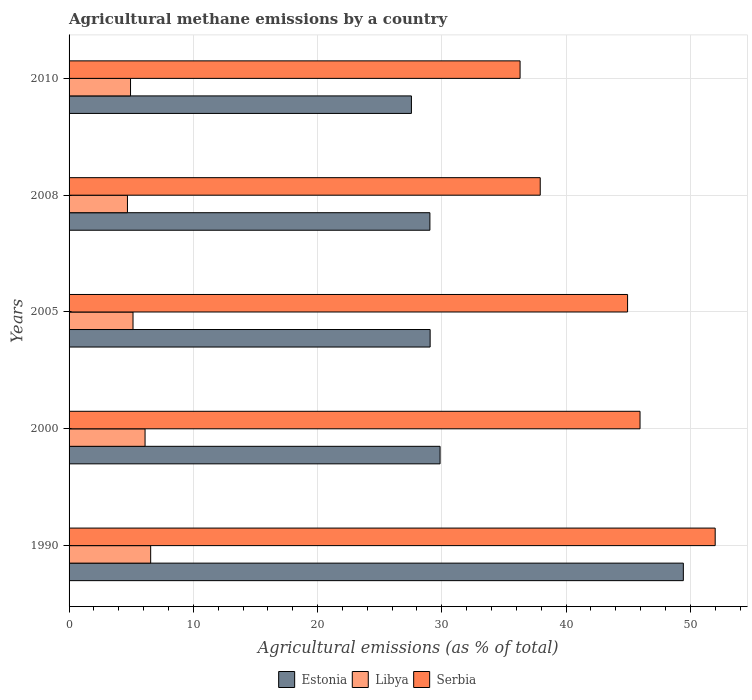How many different coloured bars are there?
Your response must be concise. 3. How many groups of bars are there?
Give a very brief answer. 5. Are the number of bars on each tick of the Y-axis equal?
Your answer should be compact. Yes. What is the label of the 5th group of bars from the top?
Make the answer very short. 1990. What is the amount of agricultural methane emitted in Estonia in 2005?
Keep it short and to the point. 29.06. Across all years, what is the maximum amount of agricultural methane emitted in Serbia?
Keep it short and to the point. 52. Across all years, what is the minimum amount of agricultural methane emitted in Libya?
Your response must be concise. 4.7. What is the total amount of agricultural methane emitted in Serbia in the graph?
Keep it short and to the point. 217.12. What is the difference between the amount of agricultural methane emitted in Libya in 1990 and that in 2010?
Your answer should be very brief. 1.62. What is the difference between the amount of agricultural methane emitted in Serbia in 2005 and the amount of agricultural methane emitted in Libya in 2008?
Your answer should be very brief. 40.25. What is the average amount of agricultural methane emitted in Estonia per year?
Ensure brevity in your answer.  32.99. In the year 2005, what is the difference between the amount of agricultural methane emitted in Estonia and amount of agricultural methane emitted in Serbia?
Your response must be concise. -15.89. What is the ratio of the amount of agricultural methane emitted in Serbia in 1990 to that in 2010?
Provide a succinct answer. 1.43. Is the amount of agricultural methane emitted in Estonia in 1990 less than that in 2005?
Your answer should be compact. No. Is the difference between the amount of agricultural methane emitted in Estonia in 1990 and 2005 greater than the difference between the amount of agricultural methane emitted in Serbia in 1990 and 2005?
Your answer should be very brief. Yes. What is the difference between the highest and the second highest amount of agricultural methane emitted in Libya?
Offer a terse response. 0.45. What is the difference between the highest and the lowest amount of agricultural methane emitted in Libya?
Offer a terse response. 1.87. In how many years, is the amount of agricultural methane emitted in Serbia greater than the average amount of agricultural methane emitted in Serbia taken over all years?
Your response must be concise. 3. Is the sum of the amount of agricultural methane emitted in Libya in 2005 and 2008 greater than the maximum amount of agricultural methane emitted in Serbia across all years?
Offer a terse response. No. What does the 1st bar from the top in 1990 represents?
Offer a terse response. Serbia. What does the 2nd bar from the bottom in 1990 represents?
Provide a succinct answer. Libya. Is it the case that in every year, the sum of the amount of agricultural methane emitted in Estonia and amount of agricultural methane emitted in Serbia is greater than the amount of agricultural methane emitted in Libya?
Your answer should be compact. Yes. How many bars are there?
Provide a succinct answer. 15. What is the difference between two consecutive major ticks on the X-axis?
Provide a succinct answer. 10. Are the values on the major ticks of X-axis written in scientific E-notation?
Your response must be concise. No. Where does the legend appear in the graph?
Offer a terse response. Bottom center. How many legend labels are there?
Keep it short and to the point. 3. What is the title of the graph?
Your answer should be very brief. Agricultural methane emissions by a country. What is the label or title of the X-axis?
Offer a very short reply. Agricultural emissions (as % of total). What is the label or title of the Y-axis?
Give a very brief answer. Years. What is the Agricultural emissions (as % of total) in Estonia in 1990?
Ensure brevity in your answer.  49.44. What is the Agricultural emissions (as % of total) of Libya in 1990?
Provide a succinct answer. 6.57. What is the Agricultural emissions (as % of total) in Serbia in 1990?
Your answer should be very brief. 52. What is the Agricultural emissions (as % of total) of Estonia in 2000?
Make the answer very short. 29.86. What is the Agricultural emissions (as % of total) in Libya in 2000?
Offer a very short reply. 6.12. What is the Agricultural emissions (as % of total) of Serbia in 2000?
Make the answer very short. 45.95. What is the Agricultural emissions (as % of total) in Estonia in 2005?
Keep it short and to the point. 29.06. What is the Agricultural emissions (as % of total) of Libya in 2005?
Your response must be concise. 5.15. What is the Agricultural emissions (as % of total) of Serbia in 2005?
Your answer should be very brief. 44.95. What is the Agricultural emissions (as % of total) in Estonia in 2008?
Your response must be concise. 29.04. What is the Agricultural emissions (as % of total) in Libya in 2008?
Give a very brief answer. 4.7. What is the Agricultural emissions (as % of total) of Serbia in 2008?
Provide a succinct answer. 37.92. What is the Agricultural emissions (as % of total) in Estonia in 2010?
Give a very brief answer. 27.55. What is the Agricultural emissions (as % of total) of Libya in 2010?
Keep it short and to the point. 4.95. What is the Agricultural emissions (as % of total) of Serbia in 2010?
Make the answer very short. 36.3. Across all years, what is the maximum Agricultural emissions (as % of total) in Estonia?
Your response must be concise. 49.44. Across all years, what is the maximum Agricultural emissions (as % of total) of Libya?
Provide a short and direct response. 6.57. Across all years, what is the maximum Agricultural emissions (as % of total) of Serbia?
Keep it short and to the point. 52. Across all years, what is the minimum Agricultural emissions (as % of total) of Estonia?
Make the answer very short. 27.55. Across all years, what is the minimum Agricultural emissions (as % of total) in Libya?
Ensure brevity in your answer.  4.7. Across all years, what is the minimum Agricultural emissions (as % of total) of Serbia?
Keep it short and to the point. 36.3. What is the total Agricultural emissions (as % of total) in Estonia in the graph?
Give a very brief answer. 164.95. What is the total Agricultural emissions (as % of total) of Libya in the graph?
Provide a succinct answer. 27.48. What is the total Agricultural emissions (as % of total) of Serbia in the graph?
Your answer should be very brief. 217.12. What is the difference between the Agricultural emissions (as % of total) in Estonia in 1990 and that in 2000?
Ensure brevity in your answer.  19.58. What is the difference between the Agricultural emissions (as % of total) in Libya in 1990 and that in 2000?
Ensure brevity in your answer.  0.45. What is the difference between the Agricultural emissions (as % of total) of Serbia in 1990 and that in 2000?
Make the answer very short. 6.05. What is the difference between the Agricultural emissions (as % of total) in Estonia in 1990 and that in 2005?
Make the answer very short. 20.38. What is the difference between the Agricultural emissions (as % of total) in Libya in 1990 and that in 2005?
Provide a short and direct response. 1.42. What is the difference between the Agricultural emissions (as % of total) in Serbia in 1990 and that in 2005?
Provide a succinct answer. 7.05. What is the difference between the Agricultural emissions (as % of total) of Estonia in 1990 and that in 2008?
Provide a short and direct response. 20.4. What is the difference between the Agricultural emissions (as % of total) in Libya in 1990 and that in 2008?
Your answer should be compact. 1.87. What is the difference between the Agricultural emissions (as % of total) in Serbia in 1990 and that in 2008?
Your response must be concise. 14.08. What is the difference between the Agricultural emissions (as % of total) in Estonia in 1990 and that in 2010?
Your answer should be very brief. 21.88. What is the difference between the Agricultural emissions (as % of total) in Libya in 1990 and that in 2010?
Your answer should be very brief. 1.62. What is the difference between the Agricultural emissions (as % of total) in Serbia in 1990 and that in 2010?
Ensure brevity in your answer.  15.7. What is the difference between the Agricultural emissions (as % of total) of Estonia in 2000 and that in 2005?
Ensure brevity in your answer.  0.8. What is the difference between the Agricultural emissions (as % of total) in Libya in 2000 and that in 2005?
Your answer should be very brief. 0.97. What is the difference between the Agricultural emissions (as % of total) of Estonia in 2000 and that in 2008?
Make the answer very short. 0.82. What is the difference between the Agricultural emissions (as % of total) in Libya in 2000 and that in 2008?
Give a very brief answer. 1.42. What is the difference between the Agricultural emissions (as % of total) of Serbia in 2000 and that in 2008?
Offer a terse response. 8.03. What is the difference between the Agricultural emissions (as % of total) of Estonia in 2000 and that in 2010?
Ensure brevity in your answer.  2.31. What is the difference between the Agricultural emissions (as % of total) of Libya in 2000 and that in 2010?
Ensure brevity in your answer.  1.17. What is the difference between the Agricultural emissions (as % of total) in Serbia in 2000 and that in 2010?
Make the answer very short. 9.65. What is the difference between the Agricultural emissions (as % of total) in Estonia in 2005 and that in 2008?
Offer a terse response. 0.02. What is the difference between the Agricultural emissions (as % of total) of Libya in 2005 and that in 2008?
Offer a very short reply. 0.45. What is the difference between the Agricultural emissions (as % of total) of Serbia in 2005 and that in 2008?
Ensure brevity in your answer.  7.03. What is the difference between the Agricultural emissions (as % of total) of Estonia in 2005 and that in 2010?
Provide a succinct answer. 1.51. What is the difference between the Agricultural emissions (as % of total) of Libya in 2005 and that in 2010?
Make the answer very short. 0.2. What is the difference between the Agricultural emissions (as % of total) in Serbia in 2005 and that in 2010?
Keep it short and to the point. 8.65. What is the difference between the Agricultural emissions (as % of total) of Estonia in 2008 and that in 2010?
Ensure brevity in your answer.  1.49. What is the difference between the Agricultural emissions (as % of total) in Libya in 2008 and that in 2010?
Offer a terse response. -0.25. What is the difference between the Agricultural emissions (as % of total) of Serbia in 2008 and that in 2010?
Make the answer very short. 1.62. What is the difference between the Agricultural emissions (as % of total) in Estonia in 1990 and the Agricultural emissions (as % of total) in Libya in 2000?
Provide a short and direct response. 43.32. What is the difference between the Agricultural emissions (as % of total) of Estonia in 1990 and the Agricultural emissions (as % of total) of Serbia in 2000?
Provide a succinct answer. 3.49. What is the difference between the Agricultural emissions (as % of total) of Libya in 1990 and the Agricultural emissions (as % of total) of Serbia in 2000?
Offer a very short reply. -39.38. What is the difference between the Agricultural emissions (as % of total) in Estonia in 1990 and the Agricultural emissions (as % of total) in Libya in 2005?
Ensure brevity in your answer.  44.29. What is the difference between the Agricultural emissions (as % of total) of Estonia in 1990 and the Agricultural emissions (as % of total) of Serbia in 2005?
Make the answer very short. 4.49. What is the difference between the Agricultural emissions (as % of total) of Libya in 1990 and the Agricultural emissions (as % of total) of Serbia in 2005?
Make the answer very short. -38.38. What is the difference between the Agricultural emissions (as % of total) in Estonia in 1990 and the Agricultural emissions (as % of total) in Libya in 2008?
Provide a succinct answer. 44.74. What is the difference between the Agricultural emissions (as % of total) of Estonia in 1990 and the Agricultural emissions (as % of total) of Serbia in 2008?
Your answer should be compact. 11.52. What is the difference between the Agricultural emissions (as % of total) of Libya in 1990 and the Agricultural emissions (as % of total) of Serbia in 2008?
Ensure brevity in your answer.  -31.35. What is the difference between the Agricultural emissions (as % of total) of Estonia in 1990 and the Agricultural emissions (as % of total) of Libya in 2010?
Provide a succinct answer. 44.49. What is the difference between the Agricultural emissions (as % of total) in Estonia in 1990 and the Agricultural emissions (as % of total) in Serbia in 2010?
Your answer should be compact. 13.14. What is the difference between the Agricultural emissions (as % of total) of Libya in 1990 and the Agricultural emissions (as % of total) of Serbia in 2010?
Your answer should be compact. -29.73. What is the difference between the Agricultural emissions (as % of total) of Estonia in 2000 and the Agricultural emissions (as % of total) of Libya in 2005?
Keep it short and to the point. 24.71. What is the difference between the Agricultural emissions (as % of total) of Estonia in 2000 and the Agricultural emissions (as % of total) of Serbia in 2005?
Give a very brief answer. -15.09. What is the difference between the Agricultural emissions (as % of total) of Libya in 2000 and the Agricultural emissions (as % of total) of Serbia in 2005?
Keep it short and to the point. -38.83. What is the difference between the Agricultural emissions (as % of total) of Estonia in 2000 and the Agricultural emissions (as % of total) of Libya in 2008?
Provide a succinct answer. 25.16. What is the difference between the Agricultural emissions (as % of total) of Estonia in 2000 and the Agricultural emissions (as % of total) of Serbia in 2008?
Your answer should be compact. -8.06. What is the difference between the Agricultural emissions (as % of total) in Libya in 2000 and the Agricultural emissions (as % of total) in Serbia in 2008?
Offer a terse response. -31.8. What is the difference between the Agricultural emissions (as % of total) of Estonia in 2000 and the Agricultural emissions (as % of total) of Libya in 2010?
Ensure brevity in your answer.  24.91. What is the difference between the Agricultural emissions (as % of total) in Estonia in 2000 and the Agricultural emissions (as % of total) in Serbia in 2010?
Your answer should be compact. -6.44. What is the difference between the Agricultural emissions (as % of total) of Libya in 2000 and the Agricultural emissions (as % of total) of Serbia in 2010?
Give a very brief answer. -30.18. What is the difference between the Agricultural emissions (as % of total) in Estonia in 2005 and the Agricultural emissions (as % of total) in Libya in 2008?
Ensure brevity in your answer.  24.36. What is the difference between the Agricultural emissions (as % of total) in Estonia in 2005 and the Agricultural emissions (as % of total) in Serbia in 2008?
Offer a terse response. -8.86. What is the difference between the Agricultural emissions (as % of total) of Libya in 2005 and the Agricultural emissions (as % of total) of Serbia in 2008?
Keep it short and to the point. -32.77. What is the difference between the Agricultural emissions (as % of total) of Estonia in 2005 and the Agricultural emissions (as % of total) of Libya in 2010?
Offer a very short reply. 24.11. What is the difference between the Agricultural emissions (as % of total) of Estonia in 2005 and the Agricultural emissions (as % of total) of Serbia in 2010?
Your response must be concise. -7.24. What is the difference between the Agricultural emissions (as % of total) in Libya in 2005 and the Agricultural emissions (as % of total) in Serbia in 2010?
Give a very brief answer. -31.15. What is the difference between the Agricultural emissions (as % of total) in Estonia in 2008 and the Agricultural emissions (as % of total) in Libya in 2010?
Offer a very short reply. 24.09. What is the difference between the Agricultural emissions (as % of total) of Estonia in 2008 and the Agricultural emissions (as % of total) of Serbia in 2010?
Your response must be concise. -7.26. What is the difference between the Agricultural emissions (as % of total) of Libya in 2008 and the Agricultural emissions (as % of total) of Serbia in 2010?
Provide a short and direct response. -31.6. What is the average Agricultural emissions (as % of total) in Estonia per year?
Your answer should be compact. 32.99. What is the average Agricultural emissions (as % of total) in Libya per year?
Make the answer very short. 5.5. What is the average Agricultural emissions (as % of total) of Serbia per year?
Make the answer very short. 43.42. In the year 1990, what is the difference between the Agricultural emissions (as % of total) in Estonia and Agricultural emissions (as % of total) in Libya?
Offer a terse response. 42.87. In the year 1990, what is the difference between the Agricultural emissions (as % of total) in Estonia and Agricultural emissions (as % of total) in Serbia?
Offer a terse response. -2.56. In the year 1990, what is the difference between the Agricultural emissions (as % of total) of Libya and Agricultural emissions (as % of total) of Serbia?
Offer a terse response. -45.43. In the year 2000, what is the difference between the Agricultural emissions (as % of total) of Estonia and Agricultural emissions (as % of total) of Libya?
Give a very brief answer. 23.74. In the year 2000, what is the difference between the Agricultural emissions (as % of total) in Estonia and Agricultural emissions (as % of total) in Serbia?
Provide a succinct answer. -16.09. In the year 2000, what is the difference between the Agricultural emissions (as % of total) of Libya and Agricultural emissions (as % of total) of Serbia?
Offer a very short reply. -39.84. In the year 2005, what is the difference between the Agricultural emissions (as % of total) in Estonia and Agricultural emissions (as % of total) in Libya?
Ensure brevity in your answer.  23.91. In the year 2005, what is the difference between the Agricultural emissions (as % of total) of Estonia and Agricultural emissions (as % of total) of Serbia?
Keep it short and to the point. -15.89. In the year 2005, what is the difference between the Agricultural emissions (as % of total) of Libya and Agricultural emissions (as % of total) of Serbia?
Your answer should be compact. -39.8. In the year 2008, what is the difference between the Agricultural emissions (as % of total) of Estonia and Agricultural emissions (as % of total) of Libya?
Make the answer very short. 24.34. In the year 2008, what is the difference between the Agricultural emissions (as % of total) in Estonia and Agricultural emissions (as % of total) in Serbia?
Provide a short and direct response. -8.88. In the year 2008, what is the difference between the Agricultural emissions (as % of total) of Libya and Agricultural emissions (as % of total) of Serbia?
Your response must be concise. -33.22. In the year 2010, what is the difference between the Agricultural emissions (as % of total) in Estonia and Agricultural emissions (as % of total) in Libya?
Provide a succinct answer. 22.61. In the year 2010, what is the difference between the Agricultural emissions (as % of total) of Estonia and Agricultural emissions (as % of total) of Serbia?
Your response must be concise. -8.74. In the year 2010, what is the difference between the Agricultural emissions (as % of total) in Libya and Agricultural emissions (as % of total) in Serbia?
Provide a short and direct response. -31.35. What is the ratio of the Agricultural emissions (as % of total) in Estonia in 1990 to that in 2000?
Give a very brief answer. 1.66. What is the ratio of the Agricultural emissions (as % of total) of Libya in 1990 to that in 2000?
Offer a very short reply. 1.07. What is the ratio of the Agricultural emissions (as % of total) in Serbia in 1990 to that in 2000?
Your response must be concise. 1.13. What is the ratio of the Agricultural emissions (as % of total) of Estonia in 1990 to that in 2005?
Your answer should be compact. 1.7. What is the ratio of the Agricultural emissions (as % of total) of Libya in 1990 to that in 2005?
Provide a succinct answer. 1.28. What is the ratio of the Agricultural emissions (as % of total) of Serbia in 1990 to that in 2005?
Your answer should be very brief. 1.16. What is the ratio of the Agricultural emissions (as % of total) in Estonia in 1990 to that in 2008?
Make the answer very short. 1.7. What is the ratio of the Agricultural emissions (as % of total) in Libya in 1990 to that in 2008?
Offer a terse response. 1.4. What is the ratio of the Agricultural emissions (as % of total) of Serbia in 1990 to that in 2008?
Your answer should be very brief. 1.37. What is the ratio of the Agricultural emissions (as % of total) in Estonia in 1990 to that in 2010?
Make the answer very short. 1.79. What is the ratio of the Agricultural emissions (as % of total) of Libya in 1990 to that in 2010?
Your answer should be very brief. 1.33. What is the ratio of the Agricultural emissions (as % of total) of Serbia in 1990 to that in 2010?
Your answer should be very brief. 1.43. What is the ratio of the Agricultural emissions (as % of total) of Estonia in 2000 to that in 2005?
Provide a succinct answer. 1.03. What is the ratio of the Agricultural emissions (as % of total) in Libya in 2000 to that in 2005?
Offer a terse response. 1.19. What is the ratio of the Agricultural emissions (as % of total) of Serbia in 2000 to that in 2005?
Your answer should be compact. 1.02. What is the ratio of the Agricultural emissions (as % of total) of Estonia in 2000 to that in 2008?
Your response must be concise. 1.03. What is the ratio of the Agricultural emissions (as % of total) in Libya in 2000 to that in 2008?
Give a very brief answer. 1.3. What is the ratio of the Agricultural emissions (as % of total) of Serbia in 2000 to that in 2008?
Provide a short and direct response. 1.21. What is the ratio of the Agricultural emissions (as % of total) in Estonia in 2000 to that in 2010?
Provide a short and direct response. 1.08. What is the ratio of the Agricultural emissions (as % of total) in Libya in 2000 to that in 2010?
Keep it short and to the point. 1.24. What is the ratio of the Agricultural emissions (as % of total) of Serbia in 2000 to that in 2010?
Give a very brief answer. 1.27. What is the ratio of the Agricultural emissions (as % of total) in Libya in 2005 to that in 2008?
Your answer should be very brief. 1.1. What is the ratio of the Agricultural emissions (as % of total) of Serbia in 2005 to that in 2008?
Make the answer very short. 1.19. What is the ratio of the Agricultural emissions (as % of total) in Estonia in 2005 to that in 2010?
Keep it short and to the point. 1.05. What is the ratio of the Agricultural emissions (as % of total) in Libya in 2005 to that in 2010?
Make the answer very short. 1.04. What is the ratio of the Agricultural emissions (as % of total) of Serbia in 2005 to that in 2010?
Make the answer very short. 1.24. What is the ratio of the Agricultural emissions (as % of total) of Estonia in 2008 to that in 2010?
Your answer should be very brief. 1.05. What is the ratio of the Agricultural emissions (as % of total) in Libya in 2008 to that in 2010?
Keep it short and to the point. 0.95. What is the ratio of the Agricultural emissions (as % of total) of Serbia in 2008 to that in 2010?
Give a very brief answer. 1.04. What is the difference between the highest and the second highest Agricultural emissions (as % of total) in Estonia?
Provide a succinct answer. 19.58. What is the difference between the highest and the second highest Agricultural emissions (as % of total) in Libya?
Your response must be concise. 0.45. What is the difference between the highest and the second highest Agricultural emissions (as % of total) of Serbia?
Make the answer very short. 6.05. What is the difference between the highest and the lowest Agricultural emissions (as % of total) in Estonia?
Offer a terse response. 21.88. What is the difference between the highest and the lowest Agricultural emissions (as % of total) of Libya?
Offer a very short reply. 1.87. What is the difference between the highest and the lowest Agricultural emissions (as % of total) in Serbia?
Provide a short and direct response. 15.7. 